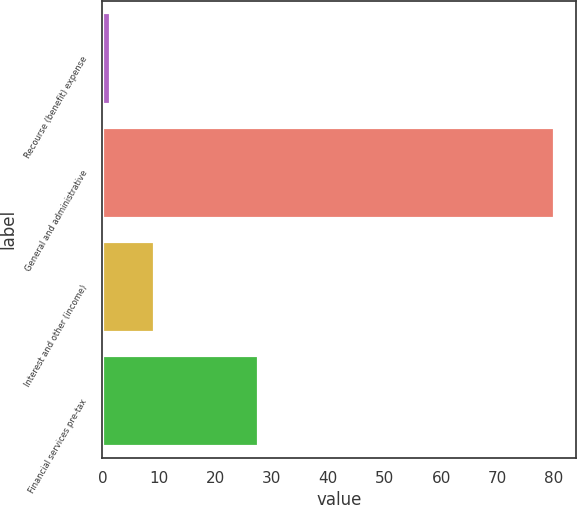Convert chart. <chart><loc_0><loc_0><loc_500><loc_500><bar_chart><fcel>Recourse (benefit) expense<fcel>General and administrative<fcel>Interest and other (income)<fcel>Financial services pre-tax<nl><fcel>1.3<fcel>79.9<fcel>9.16<fcel>27.6<nl></chart> 